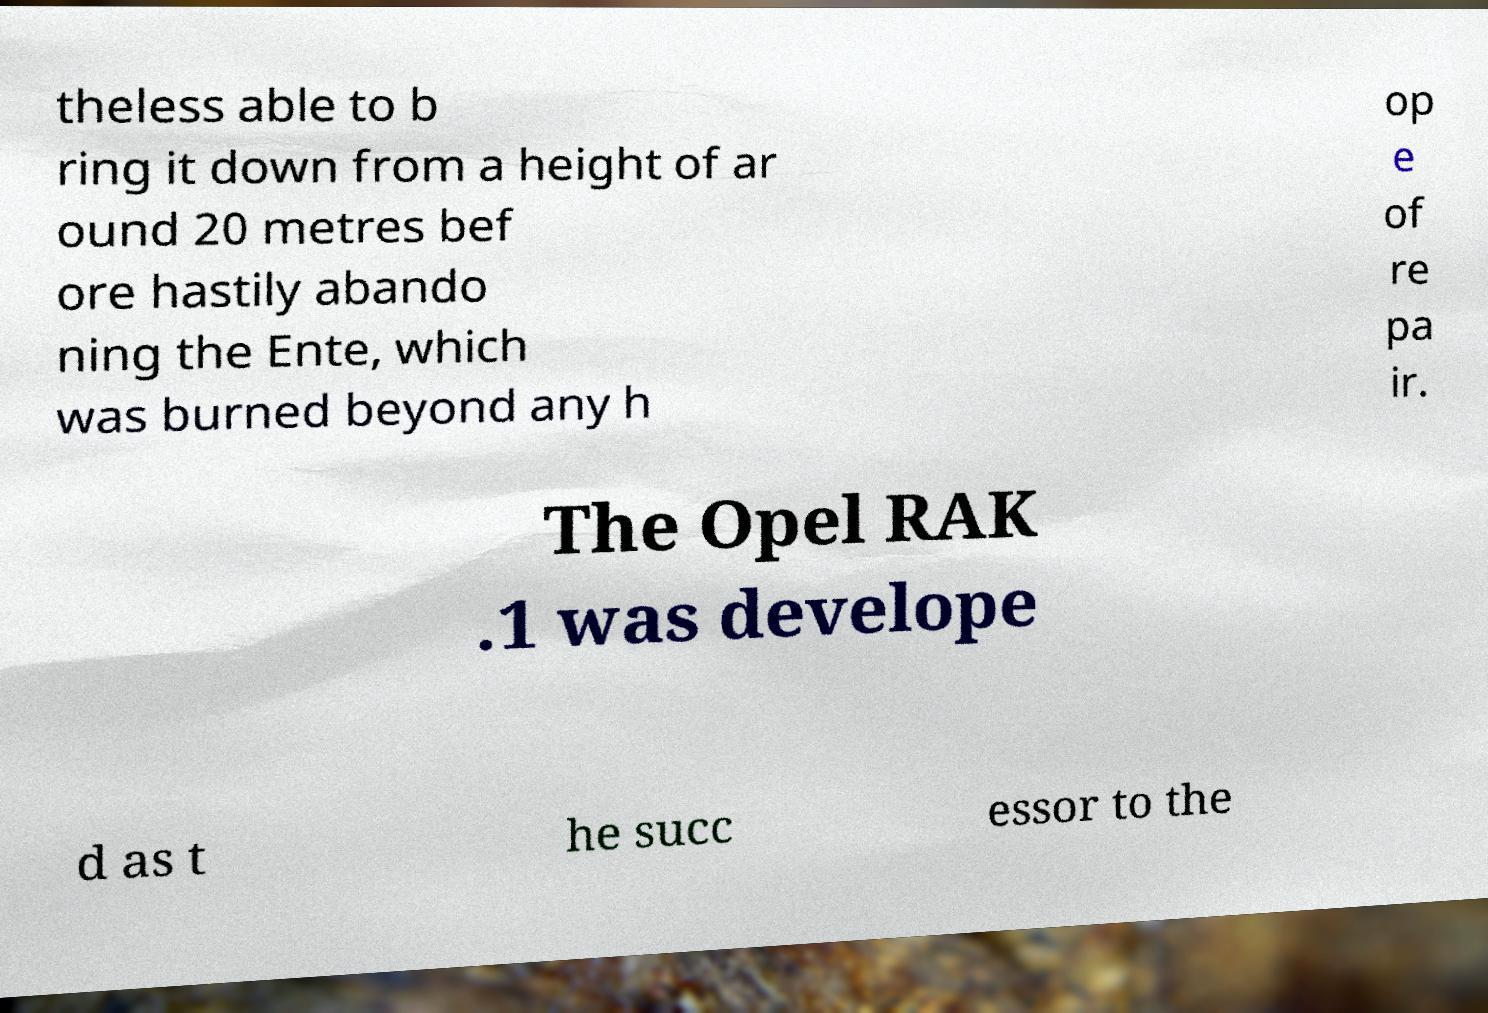Please read and relay the text visible in this image. What does it say? theless able to b ring it down from a height of ar ound 20 metres bef ore hastily abando ning the Ente, which was burned beyond any h op e of re pa ir. The Opel RAK .1 was develope d as t he succ essor to the 